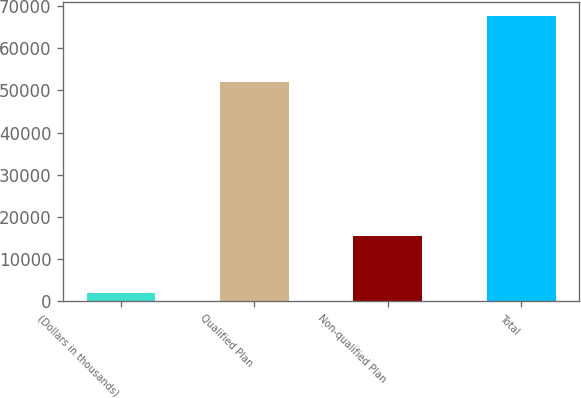Convert chart to OTSL. <chart><loc_0><loc_0><loc_500><loc_500><bar_chart><fcel>(Dollars in thousands)<fcel>Qualified Plan<fcel>Non-qualified Plan<fcel>Total<nl><fcel>2006<fcel>51937<fcel>15602<fcel>67539<nl></chart> 